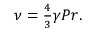Convert formula to latex. <formula><loc_0><loc_0><loc_500><loc_500>\begin{array} { r } { \nu = \frac { 4 } { 3 } \gamma P r . } \end{array}</formula> 